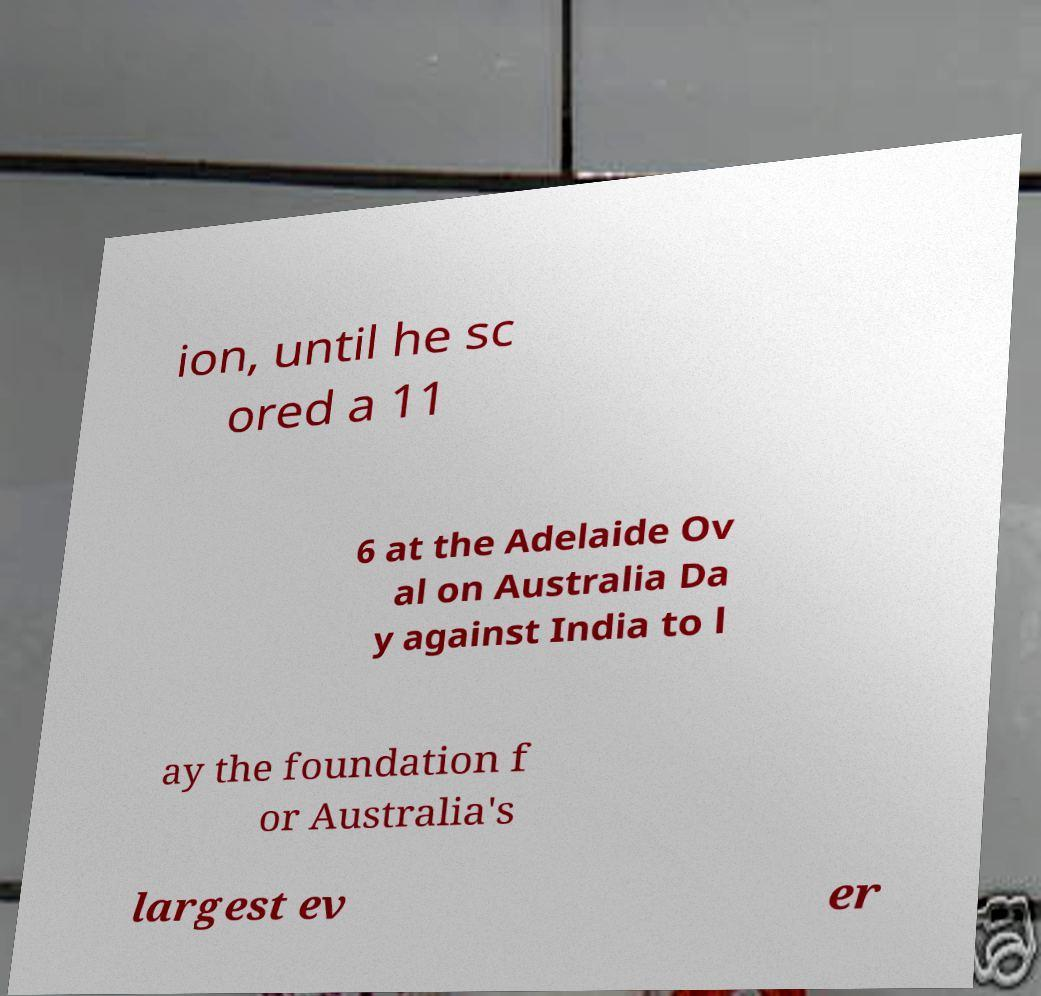There's text embedded in this image that I need extracted. Can you transcribe it verbatim? ion, until he sc ored a 11 6 at the Adelaide Ov al on Australia Da y against India to l ay the foundation f or Australia's largest ev er 